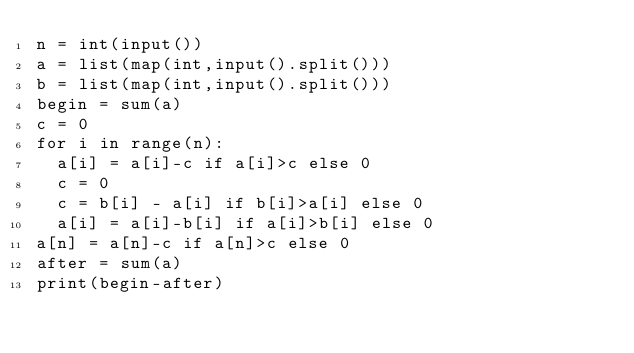Convert code to text. <code><loc_0><loc_0><loc_500><loc_500><_Python_>n = int(input())
a = list(map(int,input().split()))
b = list(map(int,input().split()))
begin = sum(a)
c = 0
for i in range(n):
  a[i] = a[i]-c if a[i]>c else 0
  c = 0
  c = b[i] - a[i] if b[i]>a[i] else 0
  a[i] = a[i]-b[i] if a[i]>b[i] else 0
a[n] = a[n]-c if a[n]>c else 0
after = sum(a)
print(begin-after)</code> 